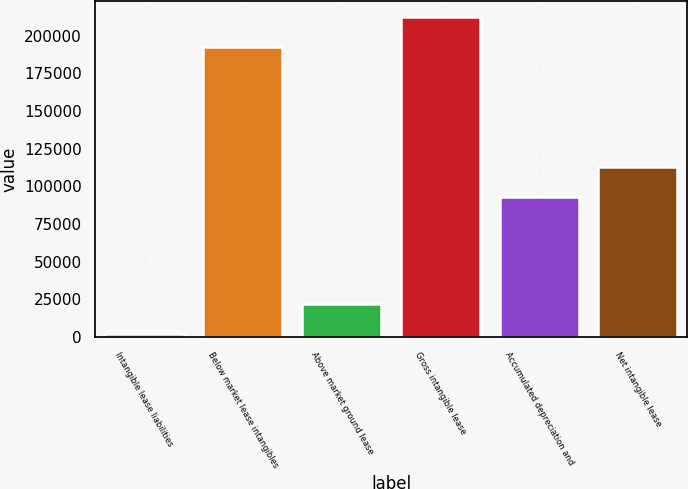<chart> <loc_0><loc_0><loc_500><loc_500><bar_chart><fcel>Intangible lease liabilities<fcel>Below market lease intangibles<fcel>Above market ground lease<fcel>Gross intangible lease<fcel>Accumulated depreciation and<fcel>Net intangible lease<nl><fcel>2012<fcel>192733<fcel>21693.2<fcel>212414<fcel>92915<fcel>112596<nl></chart> 